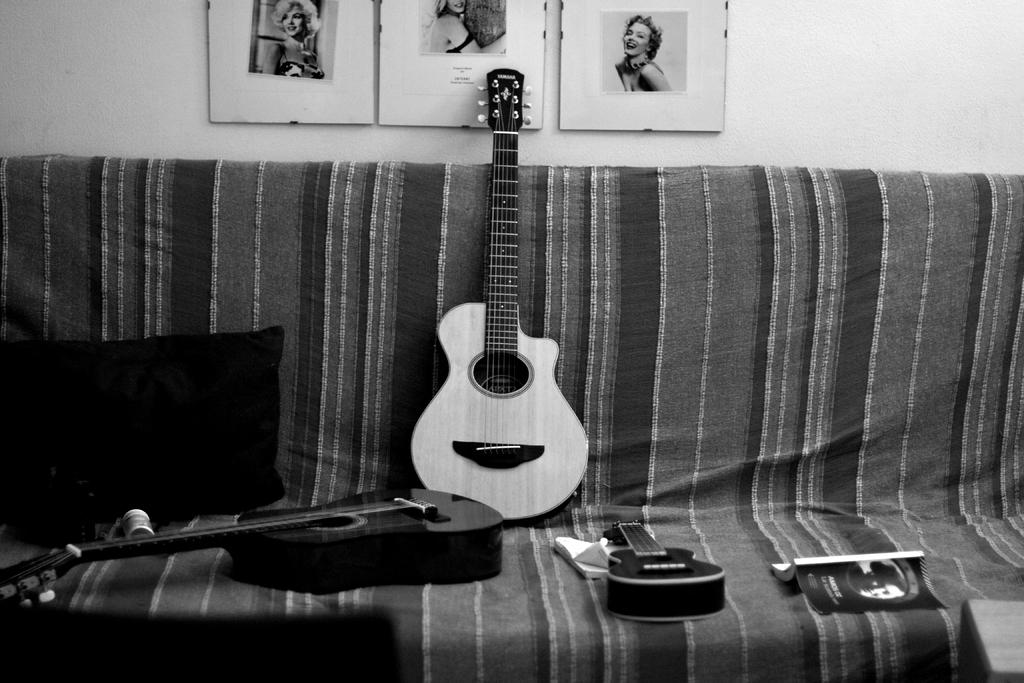What objects are placed on the couch in the image? There are guitars, a book, and a pillow on the couch in the image. What can be seen on the wall in the background? There are photos attached to the wall in the background. What might someone use for comfort while sitting on the couch? The pillow on the couch could provide comfort. What type of unit is being measured by the finger in the image? There is no finger or unit being measured in the image. 